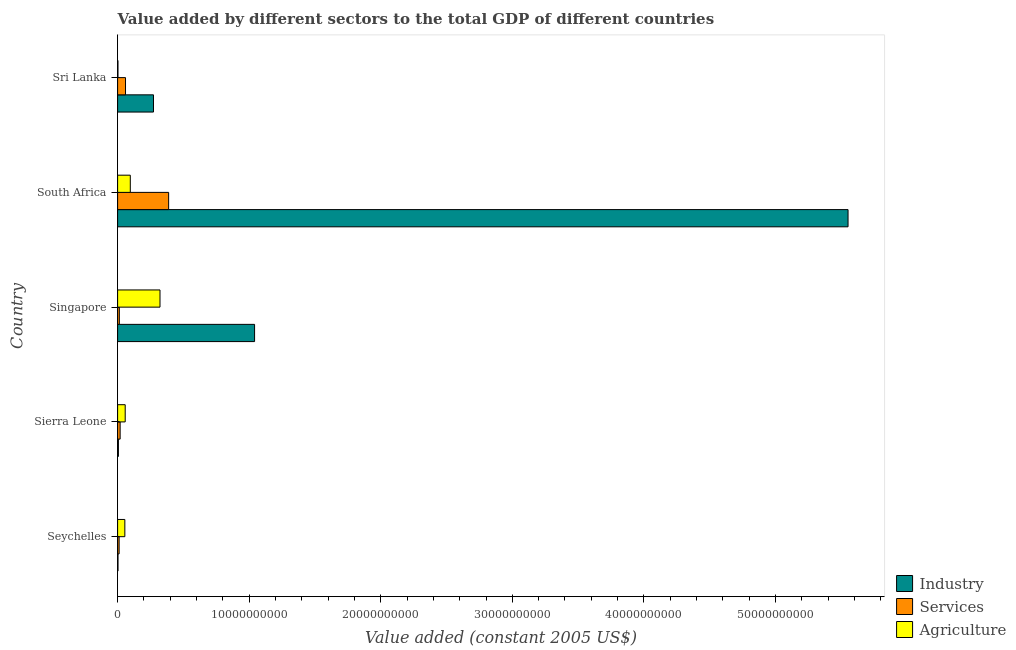How many different coloured bars are there?
Offer a very short reply. 3. How many bars are there on the 3rd tick from the bottom?
Your answer should be very brief. 3. What is the label of the 5th group of bars from the top?
Your answer should be compact. Seychelles. In how many cases, is the number of bars for a given country not equal to the number of legend labels?
Make the answer very short. 0. What is the value added by industrial sector in Sierra Leone?
Keep it short and to the point. 6.10e+07. Across all countries, what is the maximum value added by industrial sector?
Your answer should be very brief. 5.55e+1. Across all countries, what is the minimum value added by industrial sector?
Provide a succinct answer. 3.00e+07. In which country was the value added by industrial sector maximum?
Keep it short and to the point. South Africa. In which country was the value added by services minimum?
Offer a very short reply. Seychelles. What is the total value added by industrial sector in the graph?
Keep it short and to the point. 6.87e+1. What is the difference between the value added by services in Seychelles and that in Sri Lanka?
Provide a succinct answer. -4.86e+08. What is the difference between the value added by agricultural sector in Sri Lanka and the value added by industrial sector in Sierra Leone?
Offer a terse response. -3.45e+07. What is the average value added by services per country?
Your answer should be compact. 9.83e+08. What is the difference between the value added by agricultural sector and value added by industrial sector in Sri Lanka?
Make the answer very short. -2.70e+09. In how many countries, is the value added by industrial sector greater than 52000000000 US$?
Make the answer very short. 1. What is the ratio of the value added by services in Sierra Leone to that in Singapore?
Keep it short and to the point. 1.46. Is the value added by industrial sector in Sierra Leone less than that in South Africa?
Keep it short and to the point. Yes. Is the difference between the value added by industrial sector in South Africa and Sri Lanka greater than the difference between the value added by services in South Africa and Sri Lanka?
Your answer should be compact. Yes. What is the difference between the highest and the second highest value added by agricultural sector?
Your answer should be very brief. 2.26e+09. What is the difference between the highest and the lowest value added by agricultural sector?
Ensure brevity in your answer.  3.20e+09. What does the 3rd bar from the top in Sri Lanka represents?
Your answer should be compact. Industry. What does the 2nd bar from the bottom in Sierra Leone represents?
Make the answer very short. Services. What is the difference between two consecutive major ticks on the X-axis?
Offer a very short reply. 1.00e+1. Are the values on the major ticks of X-axis written in scientific E-notation?
Provide a succinct answer. No. Does the graph contain any zero values?
Your answer should be very brief. No. Where does the legend appear in the graph?
Make the answer very short. Bottom right. How many legend labels are there?
Keep it short and to the point. 3. How are the legend labels stacked?
Ensure brevity in your answer.  Vertical. What is the title of the graph?
Your answer should be very brief. Value added by different sectors to the total GDP of different countries. Does "Gaseous fuel" appear as one of the legend labels in the graph?
Ensure brevity in your answer.  No. What is the label or title of the X-axis?
Keep it short and to the point. Value added (constant 2005 US$). What is the Value added (constant 2005 US$) in Industry in Seychelles?
Your response must be concise. 3.00e+07. What is the Value added (constant 2005 US$) of Services in Seychelles?
Offer a very short reply. 1.15e+08. What is the Value added (constant 2005 US$) in Agriculture in Seychelles?
Keep it short and to the point. 5.51e+08. What is the Value added (constant 2005 US$) of Industry in Sierra Leone?
Offer a terse response. 6.10e+07. What is the Value added (constant 2005 US$) in Services in Sierra Leone?
Your answer should be compact. 1.92e+08. What is the Value added (constant 2005 US$) in Agriculture in Sierra Leone?
Provide a short and direct response. 5.77e+08. What is the Value added (constant 2005 US$) of Industry in Singapore?
Provide a short and direct response. 1.04e+1. What is the Value added (constant 2005 US$) in Services in Singapore?
Ensure brevity in your answer.  1.31e+08. What is the Value added (constant 2005 US$) of Agriculture in Singapore?
Ensure brevity in your answer.  3.22e+09. What is the Value added (constant 2005 US$) in Industry in South Africa?
Keep it short and to the point. 5.55e+1. What is the Value added (constant 2005 US$) of Services in South Africa?
Offer a terse response. 3.88e+09. What is the Value added (constant 2005 US$) in Agriculture in South Africa?
Make the answer very short. 9.65e+08. What is the Value added (constant 2005 US$) in Industry in Sri Lanka?
Keep it short and to the point. 2.73e+09. What is the Value added (constant 2005 US$) of Services in Sri Lanka?
Provide a succinct answer. 6.01e+08. What is the Value added (constant 2005 US$) in Agriculture in Sri Lanka?
Your answer should be very brief. 2.65e+07. Across all countries, what is the maximum Value added (constant 2005 US$) of Industry?
Keep it short and to the point. 5.55e+1. Across all countries, what is the maximum Value added (constant 2005 US$) in Services?
Give a very brief answer. 3.88e+09. Across all countries, what is the maximum Value added (constant 2005 US$) of Agriculture?
Offer a very short reply. 3.22e+09. Across all countries, what is the minimum Value added (constant 2005 US$) in Industry?
Make the answer very short. 3.00e+07. Across all countries, what is the minimum Value added (constant 2005 US$) in Services?
Offer a terse response. 1.15e+08. Across all countries, what is the minimum Value added (constant 2005 US$) in Agriculture?
Make the answer very short. 2.65e+07. What is the total Value added (constant 2005 US$) of Industry in the graph?
Offer a terse response. 6.87e+1. What is the total Value added (constant 2005 US$) in Services in the graph?
Your answer should be compact. 4.92e+09. What is the total Value added (constant 2005 US$) of Agriculture in the graph?
Ensure brevity in your answer.  5.34e+09. What is the difference between the Value added (constant 2005 US$) in Industry in Seychelles and that in Sierra Leone?
Your response must be concise. -3.10e+07. What is the difference between the Value added (constant 2005 US$) of Services in Seychelles and that in Sierra Leone?
Your response must be concise. -7.72e+07. What is the difference between the Value added (constant 2005 US$) of Agriculture in Seychelles and that in Sierra Leone?
Ensure brevity in your answer.  -2.68e+07. What is the difference between the Value added (constant 2005 US$) of Industry in Seychelles and that in Singapore?
Your answer should be compact. -1.04e+1. What is the difference between the Value added (constant 2005 US$) in Services in Seychelles and that in Singapore?
Offer a very short reply. -1.66e+07. What is the difference between the Value added (constant 2005 US$) in Agriculture in Seychelles and that in Singapore?
Your answer should be very brief. -2.67e+09. What is the difference between the Value added (constant 2005 US$) in Industry in Seychelles and that in South Africa?
Provide a succinct answer. -5.55e+1. What is the difference between the Value added (constant 2005 US$) in Services in Seychelles and that in South Africa?
Keep it short and to the point. -3.76e+09. What is the difference between the Value added (constant 2005 US$) of Agriculture in Seychelles and that in South Africa?
Keep it short and to the point. -4.14e+08. What is the difference between the Value added (constant 2005 US$) of Industry in Seychelles and that in Sri Lanka?
Make the answer very short. -2.70e+09. What is the difference between the Value added (constant 2005 US$) of Services in Seychelles and that in Sri Lanka?
Ensure brevity in your answer.  -4.86e+08. What is the difference between the Value added (constant 2005 US$) of Agriculture in Seychelles and that in Sri Lanka?
Provide a short and direct response. 5.24e+08. What is the difference between the Value added (constant 2005 US$) in Industry in Sierra Leone and that in Singapore?
Offer a terse response. -1.03e+1. What is the difference between the Value added (constant 2005 US$) in Services in Sierra Leone and that in Singapore?
Your response must be concise. 6.07e+07. What is the difference between the Value added (constant 2005 US$) in Agriculture in Sierra Leone and that in Singapore?
Your answer should be compact. -2.64e+09. What is the difference between the Value added (constant 2005 US$) in Industry in Sierra Leone and that in South Africa?
Your response must be concise. -5.55e+1. What is the difference between the Value added (constant 2005 US$) in Services in Sierra Leone and that in South Africa?
Give a very brief answer. -3.69e+09. What is the difference between the Value added (constant 2005 US$) of Agriculture in Sierra Leone and that in South Africa?
Offer a terse response. -3.88e+08. What is the difference between the Value added (constant 2005 US$) in Industry in Sierra Leone and that in Sri Lanka?
Your answer should be very brief. -2.67e+09. What is the difference between the Value added (constant 2005 US$) in Services in Sierra Leone and that in Sri Lanka?
Offer a very short reply. -4.09e+08. What is the difference between the Value added (constant 2005 US$) in Agriculture in Sierra Leone and that in Sri Lanka?
Ensure brevity in your answer.  5.51e+08. What is the difference between the Value added (constant 2005 US$) in Industry in Singapore and that in South Africa?
Offer a very short reply. -4.51e+1. What is the difference between the Value added (constant 2005 US$) in Services in Singapore and that in South Africa?
Keep it short and to the point. -3.75e+09. What is the difference between the Value added (constant 2005 US$) in Agriculture in Singapore and that in South Africa?
Your answer should be very brief. 2.26e+09. What is the difference between the Value added (constant 2005 US$) of Industry in Singapore and that in Sri Lanka?
Give a very brief answer. 7.68e+09. What is the difference between the Value added (constant 2005 US$) in Services in Singapore and that in Sri Lanka?
Make the answer very short. -4.70e+08. What is the difference between the Value added (constant 2005 US$) in Agriculture in Singapore and that in Sri Lanka?
Provide a succinct answer. 3.20e+09. What is the difference between the Value added (constant 2005 US$) in Industry in South Africa and that in Sri Lanka?
Make the answer very short. 5.28e+1. What is the difference between the Value added (constant 2005 US$) of Services in South Africa and that in Sri Lanka?
Make the answer very short. 3.28e+09. What is the difference between the Value added (constant 2005 US$) in Agriculture in South Africa and that in Sri Lanka?
Your answer should be compact. 9.38e+08. What is the difference between the Value added (constant 2005 US$) of Industry in Seychelles and the Value added (constant 2005 US$) of Services in Sierra Leone?
Provide a short and direct response. -1.62e+08. What is the difference between the Value added (constant 2005 US$) in Industry in Seychelles and the Value added (constant 2005 US$) in Agriculture in Sierra Leone?
Your answer should be very brief. -5.47e+08. What is the difference between the Value added (constant 2005 US$) of Services in Seychelles and the Value added (constant 2005 US$) of Agriculture in Sierra Leone?
Ensure brevity in your answer.  -4.63e+08. What is the difference between the Value added (constant 2005 US$) in Industry in Seychelles and the Value added (constant 2005 US$) in Services in Singapore?
Your answer should be compact. -1.01e+08. What is the difference between the Value added (constant 2005 US$) of Industry in Seychelles and the Value added (constant 2005 US$) of Agriculture in Singapore?
Offer a very short reply. -3.19e+09. What is the difference between the Value added (constant 2005 US$) in Services in Seychelles and the Value added (constant 2005 US$) in Agriculture in Singapore?
Keep it short and to the point. -3.11e+09. What is the difference between the Value added (constant 2005 US$) of Industry in Seychelles and the Value added (constant 2005 US$) of Services in South Africa?
Offer a terse response. -3.85e+09. What is the difference between the Value added (constant 2005 US$) in Industry in Seychelles and the Value added (constant 2005 US$) in Agriculture in South Africa?
Keep it short and to the point. -9.35e+08. What is the difference between the Value added (constant 2005 US$) of Services in Seychelles and the Value added (constant 2005 US$) of Agriculture in South Africa?
Make the answer very short. -8.50e+08. What is the difference between the Value added (constant 2005 US$) of Industry in Seychelles and the Value added (constant 2005 US$) of Services in Sri Lanka?
Offer a very short reply. -5.71e+08. What is the difference between the Value added (constant 2005 US$) in Industry in Seychelles and the Value added (constant 2005 US$) in Agriculture in Sri Lanka?
Keep it short and to the point. 3.44e+06. What is the difference between the Value added (constant 2005 US$) of Services in Seychelles and the Value added (constant 2005 US$) of Agriculture in Sri Lanka?
Ensure brevity in your answer.  8.82e+07. What is the difference between the Value added (constant 2005 US$) in Industry in Sierra Leone and the Value added (constant 2005 US$) in Services in Singapore?
Provide a succinct answer. -7.03e+07. What is the difference between the Value added (constant 2005 US$) in Industry in Sierra Leone and the Value added (constant 2005 US$) in Agriculture in Singapore?
Your answer should be compact. -3.16e+09. What is the difference between the Value added (constant 2005 US$) in Services in Sierra Leone and the Value added (constant 2005 US$) in Agriculture in Singapore?
Provide a short and direct response. -3.03e+09. What is the difference between the Value added (constant 2005 US$) of Industry in Sierra Leone and the Value added (constant 2005 US$) of Services in South Africa?
Offer a terse response. -3.82e+09. What is the difference between the Value added (constant 2005 US$) of Industry in Sierra Leone and the Value added (constant 2005 US$) of Agriculture in South Africa?
Offer a terse response. -9.04e+08. What is the difference between the Value added (constant 2005 US$) in Services in Sierra Leone and the Value added (constant 2005 US$) in Agriculture in South Africa?
Make the answer very short. -7.73e+08. What is the difference between the Value added (constant 2005 US$) of Industry in Sierra Leone and the Value added (constant 2005 US$) of Services in Sri Lanka?
Your answer should be very brief. -5.40e+08. What is the difference between the Value added (constant 2005 US$) of Industry in Sierra Leone and the Value added (constant 2005 US$) of Agriculture in Sri Lanka?
Your response must be concise. 3.45e+07. What is the difference between the Value added (constant 2005 US$) in Services in Sierra Leone and the Value added (constant 2005 US$) in Agriculture in Sri Lanka?
Offer a very short reply. 1.65e+08. What is the difference between the Value added (constant 2005 US$) of Industry in Singapore and the Value added (constant 2005 US$) of Services in South Africa?
Your response must be concise. 6.53e+09. What is the difference between the Value added (constant 2005 US$) of Industry in Singapore and the Value added (constant 2005 US$) of Agriculture in South Africa?
Provide a succinct answer. 9.45e+09. What is the difference between the Value added (constant 2005 US$) of Services in Singapore and the Value added (constant 2005 US$) of Agriculture in South Africa?
Your answer should be compact. -8.34e+08. What is the difference between the Value added (constant 2005 US$) of Industry in Singapore and the Value added (constant 2005 US$) of Services in Sri Lanka?
Offer a terse response. 9.81e+09. What is the difference between the Value added (constant 2005 US$) in Industry in Singapore and the Value added (constant 2005 US$) in Agriculture in Sri Lanka?
Offer a terse response. 1.04e+1. What is the difference between the Value added (constant 2005 US$) in Services in Singapore and the Value added (constant 2005 US$) in Agriculture in Sri Lanka?
Provide a short and direct response. 1.05e+08. What is the difference between the Value added (constant 2005 US$) in Industry in South Africa and the Value added (constant 2005 US$) in Services in Sri Lanka?
Provide a succinct answer. 5.49e+1. What is the difference between the Value added (constant 2005 US$) in Industry in South Africa and the Value added (constant 2005 US$) in Agriculture in Sri Lanka?
Offer a terse response. 5.55e+1. What is the difference between the Value added (constant 2005 US$) in Services in South Africa and the Value added (constant 2005 US$) in Agriculture in Sri Lanka?
Your answer should be very brief. 3.85e+09. What is the average Value added (constant 2005 US$) in Industry per country?
Ensure brevity in your answer.  1.37e+1. What is the average Value added (constant 2005 US$) of Services per country?
Make the answer very short. 9.83e+08. What is the average Value added (constant 2005 US$) in Agriculture per country?
Make the answer very short. 1.07e+09. What is the difference between the Value added (constant 2005 US$) in Industry and Value added (constant 2005 US$) in Services in Seychelles?
Your answer should be very brief. -8.47e+07. What is the difference between the Value added (constant 2005 US$) in Industry and Value added (constant 2005 US$) in Agriculture in Seychelles?
Provide a succinct answer. -5.21e+08. What is the difference between the Value added (constant 2005 US$) of Services and Value added (constant 2005 US$) of Agriculture in Seychelles?
Give a very brief answer. -4.36e+08. What is the difference between the Value added (constant 2005 US$) of Industry and Value added (constant 2005 US$) of Services in Sierra Leone?
Ensure brevity in your answer.  -1.31e+08. What is the difference between the Value added (constant 2005 US$) in Industry and Value added (constant 2005 US$) in Agriculture in Sierra Leone?
Your response must be concise. -5.16e+08. What is the difference between the Value added (constant 2005 US$) in Services and Value added (constant 2005 US$) in Agriculture in Sierra Leone?
Provide a short and direct response. -3.85e+08. What is the difference between the Value added (constant 2005 US$) of Industry and Value added (constant 2005 US$) of Services in Singapore?
Your answer should be very brief. 1.03e+1. What is the difference between the Value added (constant 2005 US$) in Industry and Value added (constant 2005 US$) in Agriculture in Singapore?
Provide a succinct answer. 7.19e+09. What is the difference between the Value added (constant 2005 US$) in Services and Value added (constant 2005 US$) in Agriculture in Singapore?
Ensure brevity in your answer.  -3.09e+09. What is the difference between the Value added (constant 2005 US$) of Industry and Value added (constant 2005 US$) of Services in South Africa?
Your answer should be compact. 5.16e+1. What is the difference between the Value added (constant 2005 US$) of Industry and Value added (constant 2005 US$) of Agriculture in South Africa?
Your answer should be very brief. 5.46e+1. What is the difference between the Value added (constant 2005 US$) in Services and Value added (constant 2005 US$) in Agriculture in South Africa?
Make the answer very short. 2.91e+09. What is the difference between the Value added (constant 2005 US$) of Industry and Value added (constant 2005 US$) of Services in Sri Lanka?
Ensure brevity in your answer.  2.13e+09. What is the difference between the Value added (constant 2005 US$) in Industry and Value added (constant 2005 US$) in Agriculture in Sri Lanka?
Give a very brief answer. 2.70e+09. What is the difference between the Value added (constant 2005 US$) in Services and Value added (constant 2005 US$) in Agriculture in Sri Lanka?
Your answer should be compact. 5.74e+08. What is the ratio of the Value added (constant 2005 US$) of Industry in Seychelles to that in Sierra Leone?
Keep it short and to the point. 0.49. What is the ratio of the Value added (constant 2005 US$) of Services in Seychelles to that in Sierra Leone?
Keep it short and to the point. 0.6. What is the ratio of the Value added (constant 2005 US$) in Agriculture in Seychelles to that in Sierra Leone?
Offer a very short reply. 0.95. What is the ratio of the Value added (constant 2005 US$) in Industry in Seychelles to that in Singapore?
Your answer should be compact. 0. What is the ratio of the Value added (constant 2005 US$) in Services in Seychelles to that in Singapore?
Your answer should be very brief. 0.87. What is the ratio of the Value added (constant 2005 US$) in Agriculture in Seychelles to that in Singapore?
Offer a terse response. 0.17. What is the ratio of the Value added (constant 2005 US$) in Industry in Seychelles to that in South Africa?
Provide a short and direct response. 0. What is the ratio of the Value added (constant 2005 US$) of Services in Seychelles to that in South Africa?
Give a very brief answer. 0.03. What is the ratio of the Value added (constant 2005 US$) in Agriculture in Seychelles to that in South Africa?
Give a very brief answer. 0.57. What is the ratio of the Value added (constant 2005 US$) of Industry in Seychelles to that in Sri Lanka?
Ensure brevity in your answer.  0.01. What is the ratio of the Value added (constant 2005 US$) of Services in Seychelles to that in Sri Lanka?
Offer a very short reply. 0.19. What is the ratio of the Value added (constant 2005 US$) in Agriculture in Seychelles to that in Sri Lanka?
Your response must be concise. 20.76. What is the ratio of the Value added (constant 2005 US$) in Industry in Sierra Leone to that in Singapore?
Your answer should be compact. 0.01. What is the ratio of the Value added (constant 2005 US$) of Services in Sierra Leone to that in Singapore?
Make the answer very short. 1.46. What is the ratio of the Value added (constant 2005 US$) of Agriculture in Sierra Leone to that in Singapore?
Make the answer very short. 0.18. What is the ratio of the Value added (constant 2005 US$) in Industry in Sierra Leone to that in South Africa?
Provide a succinct answer. 0. What is the ratio of the Value added (constant 2005 US$) of Services in Sierra Leone to that in South Africa?
Your response must be concise. 0.05. What is the ratio of the Value added (constant 2005 US$) of Agriculture in Sierra Leone to that in South Africa?
Offer a very short reply. 0.6. What is the ratio of the Value added (constant 2005 US$) of Industry in Sierra Leone to that in Sri Lanka?
Provide a succinct answer. 0.02. What is the ratio of the Value added (constant 2005 US$) in Services in Sierra Leone to that in Sri Lanka?
Keep it short and to the point. 0.32. What is the ratio of the Value added (constant 2005 US$) in Agriculture in Sierra Leone to that in Sri Lanka?
Your answer should be compact. 21.77. What is the ratio of the Value added (constant 2005 US$) in Industry in Singapore to that in South Africa?
Provide a short and direct response. 0.19. What is the ratio of the Value added (constant 2005 US$) in Services in Singapore to that in South Africa?
Provide a short and direct response. 0.03. What is the ratio of the Value added (constant 2005 US$) in Agriculture in Singapore to that in South Africa?
Offer a very short reply. 3.34. What is the ratio of the Value added (constant 2005 US$) of Industry in Singapore to that in Sri Lanka?
Give a very brief answer. 3.82. What is the ratio of the Value added (constant 2005 US$) in Services in Singapore to that in Sri Lanka?
Offer a very short reply. 0.22. What is the ratio of the Value added (constant 2005 US$) in Agriculture in Singapore to that in Sri Lanka?
Offer a terse response. 121.48. What is the ratio of the Value added (constant 2005 US$) of Industry in South Africa to that in Sri Lanka?
Keep it short and to the point. 20.36. What is the ratio of the Value added (constant 2005 US$) of Services in South Africa to that in Sri Lanka?
Provide a short and direct response. 6.46. What is the ratio of the Value added (constant 2005 US$) of Agriculture in South Africa to that in Sri Lanka?
Keep it short and to the point. 36.39. What is the difference between the highest and the second highest Value added (constant 2005 US$) in Industry?
Keep it short and to the point. 4.51e+1. What is the difference between the highest and the second highest Value added (constant 2005 US$) of Services?
Offer a very short reply. 3.28e+09. What is the difference between the highest and the second highest Value added (constant 2005 US$) of Agriculture?
Keep it short and to the point. 2.26e+09. What is the difference between the highest and the lowest Value added (constant 2005 US$) of Industry?
Your answer should be very brief. 5.55e+1. What is the difference between the highest and the lowest Value added (constant 2005 US$) in Services?
Your answer should be very brief. 3.76e+09. What is the difference between the highest and the lowest Value added (constant 2005 US$) of Agriculture?
Your answer should be very brief. 3.20e+09. 